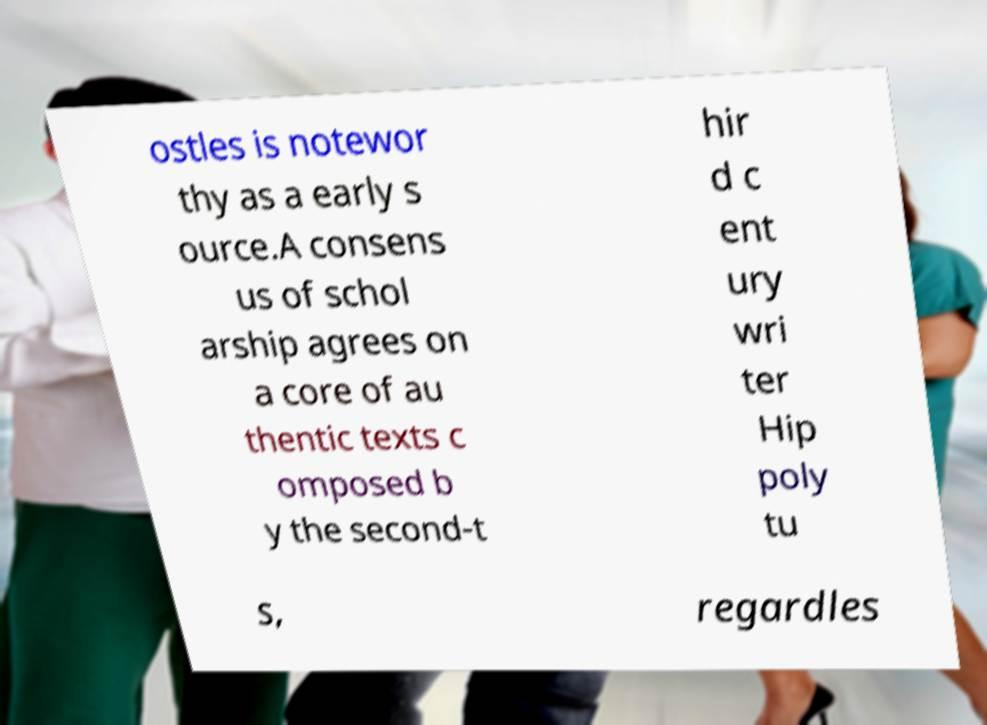Could you extract and type out the text from this image? ostles is notewor thy as a early s ource.A consens us of schol arship agrees on a core of au thentic texts c omposed b y the second-t hir d c ent ury wri ter Hip poly tu s, regardles 